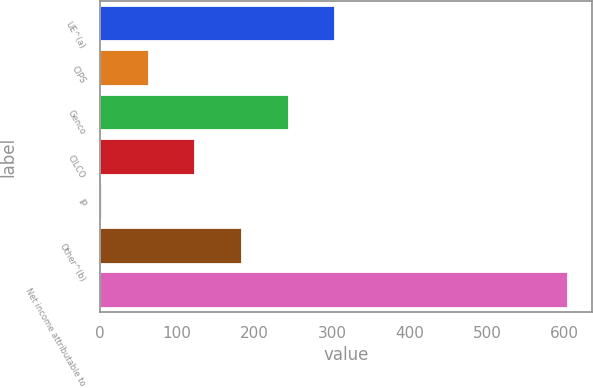Convert chart. <chart><loc_0><loc_0><loc_500><loc_500><bar_chart><fcel>UE^(a)<fcel>CIPS<fcel>Genco<fcel>CILCO<fcel>IP<fcel>Other^(b)<fcel>Net income attributable to<nl><fcel>304<fcel>63.2<fcel>243.8<fcel>123.4<fcel>3<fcel>183.6<fcel>605<nl></chart> 